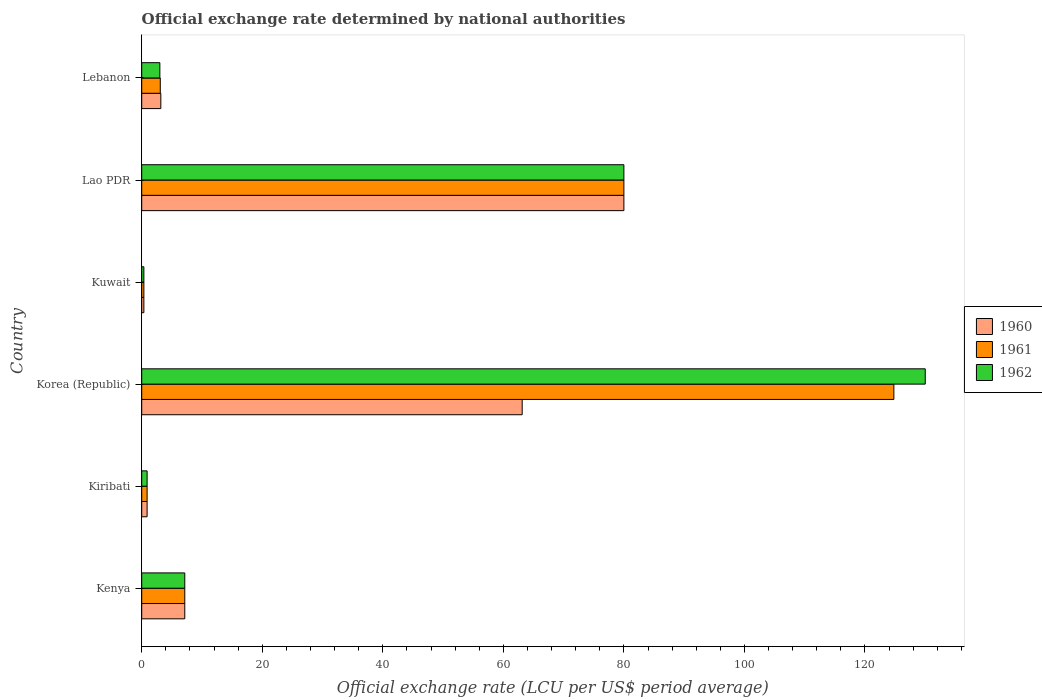How many different coloured bars are there?
Your response must be concise. 3. How many groups of bars are there?
Offer a very short reply. 6. Are the number of bars on each tick of the Y-axis equal?
Your answer should be compact. Yes. What is the label of the 6th group of bars from the top?
Offer a very short reply. Kenya. What is the official exchange rate in 1961 in Korea (Republic)?
Offer a terse response. 124.79. Across all countries, what is the maximum official exchange rate in 1962?
Your answer should be compact. 130. Across all countries, what is the minimum official exchange rate in 1962?
Give a very brief answer. 0.36. In which country was the official exchange rate in 1962 minimum?
Provide a succinct answer. Kuwait. What is the total official exchange rate in 1962 in the graph?
Make the answer very short. 221.4. What is the difference between the official exchange rate in 1960 in Kenya and that in Korea (Republic)?
Provide a succinct answer. -55.98. What is the difference between the official exchange rate in 1961 in Kiribati and the official exchange rate in 1960 in Kenya?
Give a very brief answer. -6.25. What is the average official exchange rate in 1962 per country?
Your response must be concise. 36.9. In how many countries, is the official exchange rate in 1961 greater than 128 LCU?
Provide a succinct answer. 0. What is the ratio of the official exchange rate in 1962 in Kiribati to that in Kuwait?
Your answer should be very brief. 2.5. Is the official exchange rate in 1961 in Kuwait less than that in Lao PDR?
Your response must be concise. Yes. Is the difference between the official exchange rate in 1960 in Kenya and Lebanon greater than the difference between the official exchange rate in 1961 in Kenya and Lebanon?
Offer a very short reply. No. What is the difference between the highest and the second highest official exchange rate in 1961?
Ensure brevity in your answer.  44.79. What is the difference between the highest and the lowest official exchange rate in 1960?
Offer a terse response. 79.64. In how many countries, is the official exchange rate in 1961 greater than the average official exchange rate in 1961 taken over all countries?
Offer a terse response. 2. Is the sum of the official exchange rate in 1960 in Korea (Republic) and Lao PDR greater than the maximum official exchange rate in 1961 across all countries?
Offer a very short reply. Yes. What does the 1st bar from the top in Lao PDR represents?
Ensure brevity in your answer.  1962. What does the 3rd bar from the bottom in Kuwait represents?
Your response must be concise. 1962. Is it the case that in every country, the sum of the official exchange rate in 1962 and official exchange rate in 1960 is greater than the official exchange rate in 1961?
Offer a terse response. Yes. How are the legend labels stacked?
Give a very brief answer. Vertical. What is the title of the graph?
Keep it short and to the point. Official exchange rate determined by national authorities. What is the label or title of the X-axis?
Provide a short and direct response. Official exchange rate (LCU per US$ period average). What is the Official exchange rate (LCU per US$ period average) in 1960 in Kenya?
Keep it short and to the point. 7.14. What is the Official exchange rate (LCU per US$ period average) of 1961 in Kenya?
Provide a succinct answer. 7.14. What is the Official exchange rate (LCU per US$ period average) in 1962 in Kenya?
Keep it short and to the point. 7.14. What is the Official exchange rate (LCU per US$ period average) in 1960 in Kiribati?
Your answer should be compact. 0.89. What is the Official exchange rate (LCU per US$ period average) of 1961 in Kiribati?
Offer a terse response. 0.89. What is the Official exchange rate (LCU per US$ period average) in 1962 in Kiribati?
Offer a terse response. 0.89. What is the Official exchange rate (LCU per US$ period average) of 1960 in Korea (Republic)?
Make the answer very short. 63.12. What is the Official exchange rate (LCU per US$ period average) in 1961 in Korea (Republic)?
Make the answer very short. 124.79. What is the Official exchange rate (LCU per US$ period average) in 1962 in Korea (Republic)?
Provide a succinct answer. 130. What is the Official exchange rate (LCU per US$ period average) of 1960 in Kuwait?
Provide a succinct answer. 0.36. What is the Official exchange rate (LCU per US$ period average) of 1961 in Kuwait?
Keep it short and to the point. 0.36. What is the Official exchange rate (LCU per US$ period average) of 1962 in Kuwait?
Your answer should be very brief. 0.36. What is the Official exchange rate (LCU per US$ period average) of 1960 in Lao PDR?
Provide a short and direct response. 80. What is the Official exchange rate (LCU per US$ period average) in 1961 in Lao PDR?
Provide a short and direct response. 80. What is the Official exchange rate (LCU per US$ period average) of 1962 in Lao PDR?
Offer a very short reply. 80. What is the Official exchange rate (LCU per US$ period average) in 1960 in Lebanon?
Provide a short and direct response. 3.17. What is the Official exchange rate (LCU per US$ period average) in 1961 in Lebanon?
Make the answer very short. 3.08. What is the Official exchange rate (LCU per US$ period average) of 1962 in Lebanon?
Offer a terse response. 3.01. Across all countries, what is the maximum Official exchange rate (LCU per US$ period average) in 1960?
Offer a terse response. 80. Across all countries, what is the maximum Official exchange rate (LCU per US$ period average) of 1961?
Give a very brief answer. 124.79. Across all countries, what is the maximum Official exchange rate (LCU per US$ period average) of 1962?
Provide a short and direct response. 130. Across all countries, what is the minimum Official exchange rate (LCU per US$ period average) in 1960?
Your answer should be compact. 0.36. Across all countries, what is the minimum Official exchange rate (LCU per US$ period average) of 1961?
Give a very brief answer. 0.36. Across all countries, what is the minimum Official exchange rate (LCU per US$ period average) of 1962?
Ensure brevity in your answer.  0.36. What is the total Official exchange rate (LCU per US$ period average) in 1960 in the graph?
Your response must be concise. 154.69. What is the total Official exchange rate (LCU per US$ period average) in 1961 in the graph?
Offer a terse response. 216.26. What is the total Official exchange rate (LCU per US$ period average) of 1962 in the graph?
Your response must be concise. 221.4. What is the difference between the Official exchange rate (LCU per US$ period average) of 1960 in Kenya and that in Kiribati?
Provide a short and direct response. 6.25. What is the difference between the Official exchange rate (LCU per US$ period average) of 1961 in Kenya and that in Kiribati?
Your answer should be compact. 6.25. What is the difference between the Official exchange rate (LCU per US$ period average) in 1962 in Kenya and that in Kiribati?
Offer a very short reply. 6.25. What is the difference between the Official exchange rate (LCU per US$ period average) in 1960 in Kenya and that in Korea (Republic)?
Your answer should be compact. -55.98. What is the difference between the Official exchange rate (LCU per US$ period average) in 1961 in Kenya and that in Korea (Republic)?
Ensure brevity in your answer.  -117.65. What is the difference between the Official exchange rate (LCU per US$ period average) in 1962 in Kenya and that in Korea (Republic)?
Give a very brief answer. -122.86. What is the difference between the Official exchange rate (LCU per US$ period average) of 1960 in Kenya and that in Kuwait?
Provide a short and direct response. 6.79. What is the difference between the Official exchange rate (LCU per US$ period average) in 1961 in Kenya and that in Kuwait?
Your answer should be very brief. 6.79. What is the difference between the Official exchange rate (LCU per US$ period average) in 1962 in Kenya and that in Kuwait?
Offer a very short reply. 6.79. What is the difference between the Official exchange rate (LCU per US$ period average) in 1960 in Kenya and that in Lao PDR?
Your answer should be very brief. -72.86. What is the difference between the Official exchange rate (LCU per US$ period average) in 1961 in Kenya and that in Lao PDR?
Your response must be concise. -72.86. What is the difference between the Official exchange rate (LCU per US$ period average) in 1962 in Kenya and that in Lao PDR?
Your answer should be compact. -72.86. What is the difference between the Official exchange rate (LCU per US$ period average) in 1960 in Kenya and that in Lebanon?
Your response must be concise. 3.97. What is the difference between the Official exchange rate (LCU per US$ period average) in 1961 in Kenya and that in Lebanon?
Your answer should be very brief. 4.06. What is the difference between the Official exchange rate (LCU per US$ period average) in 1962 in Kenya and that in Lebanon?
Provide a succinct answer. 4.13. What is the difference between the Official exchange rate (LCU per US$ period average) of 1960 in Kiribati and that in Korea (Republic)?
Your answer should be very brief. -62.23. What is the difference between the Official exchange rate (LCU per US$ period average) in 1961 in Kiribati and that in Korea (Republic)?
Your answer should be very brief. -123.9. What is the difference between the Official exchange rate (LCU per US$ period average) of 1962 in Kiribati and that in Korea (Republic)?
Offer a very short reply. -129.11. What is the difference between the Official exchange rate (LCU per US$ period average) in 1960 in Kiribati and that in Kuwait?
Provide a short and direct response. 0.54. What is the difference between the Official exchange rate (LCU per US$ period average) of 1961 in Kiribati and that in Kuwait?
Give a very brief answer. 0.54. What is the difference between the Official exchange rate (LCU per US$ period average) of 1962 in Kiribati and that in Kuwait?
Give a very brief answer. 0.54. What is the difference between the Official exchange rate (LCU per US$ period average) in 1960 in Kiribati and that in Lao PDR?
Provide a short and direct response. -79.11. What is the difference between the Official exchange rate (LCU per US$ period average) in 1961 in Kiribati and that in Lao PDR?
Your answer should be very brief. -79.11. What is the difference between the Official exchange rate (LCU per US$ period average) in 1962 in Kiribati and that in Lao PDR?
Provide a succinct answer. -79.11. What is the difference between the Official exchange rate (LCU per US$ period average) of 1960 in Kiribati and that in Lebanon?
Make the answer very short. -2.28. What is the difference between the Official exchange rate (LCU per US$ period average) in 1961 in Kiribati and that in Lebanon?
Make the answer very short. -2.19. What is the difference between the Official exchange rate (LCU per US$ period average) in 1962 in Kiribati and that in Lebanon?
Your answer should be compact. -2.12. What is the difference between the Official exchange rate (LCU per US$ period average) in 1960 in Korea (Republic) and that in Kuwait?
Make the answer very short. 62.77. What is the difference between the Official exchange rate (LCU per US$ period average) of 1961 in Korea (Republic) and that in Kuwait?
Keep it short and to the point. 124.43. What is the difference between the Official exchange rate (LCU per US$ period average) of 1962 in Korea (Republic) and that in Kuwait?
Make the answer very short. 129.64. What is the difference between the Official exchange rate (LCU per US$ period average) in 1960 in Korea (Republic) and that in Lao PDR?
Ensure brevity in your answer.  -16.88. What is the difference between the Official exchange rate (LCU per US$ period average) in 1961 in Korea (Republic) and that in Lao PDR?
Ensure brevity in your answer.  44.79. What is the difference between the Official exchange rate (LCU per US$ period average) in 1962 in Korea (Republic) and that in Lao PDR?
Make the answer very short. 50. What is the difference between the Official exchange rate (LCU per US$ period average) of 1960 in Korea (Republic) and that in Lebanon?
Offer a very short reply. 59.96. What is the difference between the Official exchange rate (LCU per US$ period average) in 1961 in Korea (Republic) and that in Lebanon?
Make the answer very short. 121.71. What is the difference between the Official exchange rate (LCU per US$ period average) of 1962 in Korea (Republic) and that in Lebanon?
Give a very brief answer. 126.99. What is the difference between the Official exchange rate (LCU per US$ period average) of 1960 in Kuwait and that in Lao PDR?
Offer a terse response. -79.64. What is the difference between the Official exchange rate (LCU per US$ period average) of 1961 in Kuwait and that in Lao PDR?
Offer a very short reply. -79.64. What is the difference between the Official exchange rate (LCU per US$ period average) in 1962 in Kuwait and that in Lao PDR?
Your answer should be compact. -79.64. What is the difference between the Official exchange rate (LCU per US$ period average) of 1960 in Kuwait and that in Lebanon?
Keep it short and to the point. -2.81. What is the difference between the Official exchange rate (LCU per US$ period average) in 1961 in Kuwait and that in Lebanon?
Offer a terse response. -2.72. What is the difference between the Official exchange rate (LCU per US$ period average) in 1962 in Kuwait and that in Lebanon?
Give a very brief answer. -2.65. What is the difference between the Official exchange rate (LCU per US$ period average) in 1960 in Lao PDR and that in Lebanon?
Offer a terse response. 76.83. What is the difference between the Official exchange rate (LCU per US$ period average) of 1961 in Lao PDR and that in Lebanon?
Your answer should be compact. 76.92. What is the difference between the Official exchange rate (LCU per US$ period average) of 1962 in Lao PDR and that in Lebanon?
Keep it short and to the point. 76.99. What is the difference between the Official exchange rate (LCU per US$ period average) of 1960 in Kenya and the Official exchange rate (LCU per US$ period average) of 1961 in Kiribati?
Give a very brief answer. 6.25. What is the difference between the Official exchange rate (LCU per US$ period average) of 1960 in Kenya and the Official exchange rate (LCU per US$ period average) of 1962 in Kiribati?
Provide a short and direct response. 6.25. What is the difference between the Official exchange rate (LCU per US$ period average) of 1961 in Kenya and the Official exchange rate (LCU per US$ period average) of 1962 in Kiribati?
Your answer should be very brief. 6.25. What is the difference between the Official exchange rate (LCU per US$ period average) of 1960 in Kenya and the Official exchange rate (LCU per US$ period average) of 1961 in Korea (Republic)?
Keep it short and to the point. -117.65. What is the difference between the Official exchange rate (LCU per US$ period average) of 1960 in Kenya and the Official exchange rate (LCU per US$ period average) of 1962 in Korea (Republic)?
Provide a short and direct response. -122.86. What is the difference between the Official exchange rate (LCU per US$ period average) in 1961 in Kenya and the Official exchange rate (LCU per US$ period average) in 1962 in Korea (Republic)?
Make the answer very short. -122.86. What is the difference between the Official exchange rate (LCU per US$ period average) of 1960 in Kenya and the Official exchange rate (LCU per US$ period average) of 1961 in Kuwait?
Your answer should be very brief. 6.79. What is the difference between the Official exchange rate (LCU per US$ period average) in 1960 in Kenya and the Official exchange rate (LCU per US$ period average) in 1962 in Kuwait?
Give a very brief answer. 6.79. What is the difference between the Official exchange rate (LCU per US$ period average) in 1961 in Kenya and the Official exchange rate (LCU per US$ period average) in 1962 in Kuwait?
Your answer should be compact. 6.79. What is the difference between the Official exchange rate (LCU per US$ period average) in 1960 in Kenya and the Official exchange rate (LCU per US$ period average) in 1961 in Lao PDR?
Give a very brief answer. -72.86. What is the difference between the Official exchange rate (LCU per US$ period average) in 1960 in Kenya and the Official exchange rate (LCU per US$ period average) in 1962 in Lao PDR?
Offer a terse response. -72.86. What is the difference between the Official exchange rate (LCU per US$ period average) of 1961 in Kenya and the Official exchange rate (LCU per US$ period average) of 1962 in Lao PDR?
Offer a very short reply. -72.86. What is the difference between the Official exchange rate (LCU per US$ period average) of 1960 in Kenya and the Official exchange rate (LCU per US$ period average) of 1961 in Lebanon?
Provide a short and direct response. 4.06. What is the difference between the Official exchange rate (LCU per US$ period average) in 1960 in Kenya and the Official exchange rate (LCU per US$ period average) in 1962 in Lebanon?
Your answer should be very brief. 4.13. What is the difference between the Official exchange rate (LCU per US$ period average) of 1961 in Kenya and the Official exchange rate (LCU per US$ period average) of 1962 in Lebanon?
Provide a short and direct response. 4.13. What is the difference between the Official exchange rate (LCU per US$ period average) in 1960 in Kiribati and the Official exchange rate (LCU per US$ period average) in 1961 in Korea (Republic)?
Keep it short and to the point. -123.9. What is the difference between the Official exchange rate (LCU per US$ period average) of 1960 in Kiribati and the Official exchange rate (LCU per US$ period average) of 1962 in Korea (Republic)?
Offer a terse response. -129.11. What is the difference between the Official exchange rate (LCU per US$ period average) of 1961 in Kiribati and the Official exchange rate (LCU per US$ period average) of 1962 in Korea (Republic)?
Your answer should be compact. -129.11. What is the difference between the Official exchange rate (LCU per US$ period average) in 1960 in Kiribati and the Official exchange rate (LCU per US$ period average) in 1961 in Kuwait?
Provide a short and direct response. 0.54. What is the difference between the Official exchange rate (LCU per US$ period average) in 1960 in Kiribati and the Official exchange rate (LCU per US$ period average) in 1962 in Kuwait?
Provide a short and direct response. 0.54. What is the difference between the Official exchange rate (LCU per US$ period average) of 1961 in Kiribati and the Official exchange rate (LCU per US$ period average) of 1962 in Kuwait?
Keep it short and to the point. 0.54. What is the difference between the Official exchange rate (LCU per US$ period average) of 1960 in Kiribati and the Official exchange rate (LCU per US$ period average) of 1961 in Lao PDR?
Make the answer very short. -79.11. What is the difference between the Official exchange rate (LCU per US$ period average) in 1960 in Kiribati and the Official exchange rate (LCU per US$ period average) in 1962 in Lao PDR?
Ensure brevity in your answer.  -79.11. What is the difference between the Official exchange rate (LCU per US$ period average) of 1961 in Kiribati and the Official exchange rate (LCU per US$ period average) of 1962 in Lao PDR?
Offer a very short reply. -79.11. What is the difference between the Official exchange rate (LCU per US$ period average) in 1960 in Kiribati and the Official exchange rate (LCU per US$ period average) in 1961 in Lebanon?
Offer a very short reply. -2.19. What is the difference between the Official exchange rate (LCU per US$ period average) in 1960 in Kiribati and the Official exchange rate (LCU per US$ period average) in 1962 in Lebanon?
Offer a very short reply. -2.12. What is the difference between the Official exchange rate (LCU per US$ period average) of 1961 in Kiribati and the Official exchange rate (LCU per US$ period average) of 1962 in Lebanon?
Make the answer very short. -2.12. What is the difference between the Official exchange rate (LCU per US$ period average) of 1960 in Korea (Republic) and the Official exchange rate (LCU per US$ period average) of 1961 in Kuwait?
Offer a terse response. 62.77. What is the difference between the Official exchange rate (LCU per US$ period average) of 1960 in Korea (Republic) and the Official exchange rate (LCU per US$ period average) of 1962 in Kuwait?
Your answer should be very brief. 62.77. What is the difference between the Official exchange rate (LCU per US$ period average) in 1961 in Korea (Republic) and the Official exchange rate (LCU per US$ period average) in 1962 in Kuwait?
Your answer should be compact. 124.43. What is the difference between the Official exchange rate (LCU per US$ period average) of 1960 in Korea (Republic) and the Official exchange rate (LCU per US$ period average) of 1961 in Lao PDR?
Keep it short and to the point. -16.88. What is the difference between the Official exchange rate (LCU per US$ period average) in 1960 in Korea (Republic) and the Official exchange rate (LCU per US$ period average) in 1962 in Lao PDR?
Offer a terse response. -16.88. What is the difference between the Official exchange rate (LCU per US$ period average) in 1961 in Korea (Republic) and the Official exchange rate (LCU per US$ period average) in 1962 in Lao PDR?
Provide a short and direct response. 44.79. What is the difference between the Official exchange rate (LCU per US$ period average) of 1960 in Korea (Republic) and the Official exchange rate (LCU per US$ period average) of 1961 in Lebanon?
Provide a short and direct response. 60.05. What is the difference between the Official exchange rate (LCU per US$ period average) of 1960 in Korea (Republic) and the Official exchange rate (LCU per US$ period average) of 1962 in Lebanon?
Ensure brevity in your answer.  60.12. What is the difference between the Official exchange rate (LCU per US$ period average) of 1961 in Korea (Republic) and the Official exchange rate (LCU per US$ period average) of 1962 in Lebanon?
Give a very brief answer. 121.78. What is the difference between the Official exchange rate (LCU per US$ period average) of 1960 in Kuwait and the Official exchange rate (LCU per US$ period average) of 1961 in Lao PDR?
Offer a terse response. -79.64. What is the difference between the Official exchange rate (LCU per US$ period average) in 1960 in Kuwait and the Official exchange rate (LCU per US$ period average) in 1962 in Lao PDR?
Your response must be concise. -79.64. What is the difference between the Official exchange rate (LCU per US$ period average) of 1961 in Kuwait and the Official exchange rate (LCU per US$ period average) of 1962 in Lao PDR?
Ensure brevity in your answer.  -79.64. What is the difference between the Official exchange rate (LCU per US$ period average) of 1960 in Kuwait and the Official exchange rate (LCU per US$ period average) of 1961 in Lebanon?
Provide a short and direct response. -2.72. What is the difference between the Official exchange rate (LCU per US$ period average) in 1960 in Kuwait and the Official exchange rate (LCU per US$ period average) in 1962 in Lebanon?
Provide a succinct answer. -2.65. What is the difference between the Official exchange rate (LCU per US$ period average) of 1961 in Kuwait and the Official exchange rate (LCU per US$ period average) of 1962 in Lebanon?
Provide a short and direct response. -2.65. What is the difference between the Official exchange rate (LCU per US$ period average) in 1960 in Lao PDR and the Official exchange rate (LCU per US$ period average) in 1961 in Lebanon?
Provide a succinct answer. 76.92. What is the difference between the Official exchange rate (LCU per US$ period average) of 1960 in Lao PDR and the Official exchange rate (LCU per US$ period average) of 1962 in Lebanon?
Ensure brevity in your answer.  76.99. What is the difference between the Official exchange rate (LCU per US$ period average) of 1961 in Lao PDR and the Official exchange rate (LCU per US$ period average) of 1962 in Lebanon?
Your response must be concise. 76.99. What is the average Official exchange rate (LCU per US$ period average) of 1960 per country?
Keep it short and to the point. 25.78. What is the average Official exchange rate (LCU per US$ period average) in 1961 per country?
Provide a short and direct response. 36.04. What is the average Official exchange rate (LCU per US$ period average) in 1962 per country?
Offer a terse response. 36.9. What is the difference between the Official exchange rate (LCU per US$ period average) in 1960 and Official exchange rate (LCU per US$ period average) in 1961 in Kenya?
Make the answer very short. 0. What is the difference between the Official exchange rate (LCU per US$ period average) in 1960 and Official exchange rate (LCU per US$ period average) in 1962 in Kenya?
Your answer should be compact. 0. What is the difference between the Official exchange rate (LCU per US$ period average) of 1960 and Official exchange rate (LCU per US$ period average) of 1961 in Kiribati?
Provide a short and direct response. 0. What is the difference between the Official exchange rate (LCU per US$ period average) in 1961 and Official exchange rate (LCU per US$ period average) in 1962 in Kiribati?
Offer a terse response. 0. What is the difference between the Official exchange rate (LCU per US$ period average) in 1960 and Official exchange rate (LCU per US$ period average) in 1961 in Korea (Republic)?
Offer a very short reply. -61.67. What is the difference between the Official exchange rate (LCU per US$ period average) of 1960 and Official exchange rate (LCU per US$ period average) of 1962 in Korea (Republic)?
Your response must be concise. -66.88. What is the difference between the Official exchange rate (LCU per US$ period average) in 1961 and Official exchange rate (LCU per US$ period average) in 1962 in Korea (Republic)?
Offer a terse response. -5.21. What is the difference between the Official exchange rate (LCU per US$ period average) of 1960 and Official exchange rate (LCU per US$ period average) of 1961 in Kuwait?
Give a very brief answer. 0. What is the difference between the Official exchange rate (LCU per US$ period average) in 1961 and Official exchange rate (LCU per US$ period average) in 1962 in Lao PDR?
Give a very brief answer. 0. What is the difference between the Official exchange rate (LCU per US$ period average) of 1960 and Official exchange rate (LCU per US$ period average) of 1961 in Lebanon?
Make the answer very short. 0.09. What is the difference between the Official exchange rate (LCU per US$ period average) of 1960 and Official exchange rate (LCU per US$ period average) of 1962 in Lebanon?
Your response must be concise. 0.16. What is the difference between the Official exchange rate (LCU per US$ period average) of 1961 and Official exchange rate (LCU per US$ period average) of 1962 in Lebanon?
Your response must be concise. 0.07. What is the ratio of the Official exchange rate (LCU per US$ period average) of 1961 in Kenya to that in Kiribati?
Provide a succinct answer. 8. What is the ratio of the Official exchange rate (LCU per US$ period average) of 1962 in Kenya to that in Kiribati?
Provide a short and direct response. 8. What is the ratio of the Official exchange rate (LCU per US$ period average) of 1960 in Kenya to that in Korea (Republic)?
Provide a succinct answer. 0.11. What is the ratio of the Official exchange rate (LCU per US$ period average) in 1961 in Kenya to that in Korea (Republic)?
Provide a short and direct response. 0.06. What is the ratio of the Official exchange rate (LCU per US$ period average) in 1962 in Kenya to that in Korea (Republic)?
Provide a short and direct response. 0.05. What is the ratio of the Official exchange rate (LCU per US$ period average) of 1960 in Kenya to that in Kuwait?
Give a very brief answer. 20. What is the ratio of the Official exchange rate (LCU per US$ period average) of 1961 in Kenya to that in Kuwait?
Ensure brevity in your answer.  20. What is the ratio of the Official exchange rate (LCU per US$ period average) of 1960 in Kenya to that in Lao PDR?
Give a very brief answer. 0.09. What is the ratio of the Official exchange rate (LCU per US$ period average) in 1961 in Kenya to that in Lao PDR?
Keep it short and to the point. 0.09. What is the ratio of the Official exchange rate (LCU per US$ period average) of 1962 in Kenya to that in Lao PDR?
Make the answer very short. 0.09. What is the ratio of the Official exchange rate (LCU per US$ period average) in 1960 in Kenya to that in Lebanon?
Your answer should be compact. 2.25. What is the ratio of the Official exchange rate (LCU per US$ period average) in 1961 in Kenya to that in Lebanon?
Give a very brief answer. 2.32. What is the ratio of the Official exchange rate (LCU per US$ period average) in 1962 in Kenya to that in Lebanon?
Your answer should be very brief. 2.37. What is the ratio of the Official exchange rate (LCU per US$ period average) of 1960 in Kiribati to that in Korea (Republic)?
Offer a very short reply. 0.01. What is the ratio of the Official exchange rate (LCU per US$ period average) of 1961 in Kiribati to that in Korea (Republic)?
Your answer should be very brief. 0.01. What is the ratio of the Official exchange rate (LCU per US$ period average) in 1962 in Kiribati to that in Korea (Republic)?
Your response must be concise. 0.01. What is the ratio of the Official exchange rate (LCU per US$ period average) in 1960 in Kiribati to that in Lao PDR?
Your answer should be very brief. 0.01. What is the ratio of the Official exchange rate (LCU per US$ period average) in 1961 in Kiribati to that in Lao PDR?
Keep it short and to the point. 0.01. What is the ratio of the Official exchange rate (LCU per US$ period average) of 1962 in Kiribati to that in Lao PDR?
Offer a terse response. 0.01. What is the ratio of the Official exchange rate (LCU per US$ period average) in 1960 in Kiribati to that in Lebanon?
Your response must be concise. 0.28. What is the ratio of the Official exchange rate (LCU per US$ period average) of 1961 in Kiribati to that in Lebanon?
Make the answer very short. 0.29. What is the ratio of the Official exchange rate (LCU per US$ period average) of 1962 in Kiribati to that in Lebanon?
Provide a short and direct response. 0.3. What is the ratio of the Official exchange rate (LCU per US$ period average) of 1960 in Korea (Republic) to that in Kuwait?
Keep it short and to the point. 176.75. What is the ratio of the Official exchange rate (LCU per US$ period average) in 1961 in Korea (Republic) to that in Kuwait?
Your response must be concise. 349.42. What is the ratio of the Official exchange rate (LCU per US$ period average) in 1962 in Korea (Republic) to that in Kuwait?
Give a very brief answer. 364. What is the ratio of the Official exchange rate (LCU per US$ period average) in 1960 in Korea (Republic) to that in Lao PDR?
Offer a terse response. 0.79. What is the ratio of the Official exchange rate (LCU per US$ period average) in 1961 in Korea (Republic) to that in Lao PDR?
Provide a succinct answer. 1.56. What is the ratio of the Official exchange rate (LCU per US$ period average) in 1962 in Korea (Republic) to that in Lao PDR?
Provide a short and direct response. 1.62. What is the ratio of the Official exchange rate (LCU per US$ period average) of 1960 in Korea (Republic) to that in Lebanon?
Give a very brief answer. 19.92. What is the ratio of the Official exchange rate (LCU per US$ period average) in 1961 in Korea (Republic) to that in Lebanon?
Provide a short and direct response. 40.53. What is the ratio of the Official exchange rate (LCU per US$ period average) of 1962 in Korea (Republic) to that in Lebanon?
Your response must be concise. 43.2. What is the ratio of the Official exchange rate (LCU per US$ period average) of 1960 in Kuwait to that in Lao PDR?
Your answer should be very brief. 0. What is the ratio of the Official exchange rate (LCU per US$ period average) of 1961 in Kuwait to that in Lao PDR?
Your answer should be compact. 0. What is the ratio of the Official exchange rate (LCU per US$ period average) in 1962 in Kuwait to that in Lao PDR?
Offer a very short reply. 0. What is the ratio of the Official exchange rate (LCU per US$ period average) of 1960 in Kuwait to that in Lebanon?
Your answer should be compact. 0.11. What is the ratio of the Official exchange rate (LCU per US$ period average) in 1961 in Kuwait to that in Lebanon?
Offer a very short reply. 0.12. What is the ratio of the Official exchange rate (LCU per US$ period average) of 1962 in Kuwait to that in Lebanon?
Your answer should be very brief. 0.12. What is the ratio of the Official exchange rate (LCU per US$ period average) of 1960 in Lao PDR to that in Lebanon?
Keep it short and to the point. 25.24. What is the ratio of the Official exchange rate (LCU per US$ period average) in 1961 in Lao PDR to that in Lebanon?
Your response must be concise. 25.99. What is the ratio of the Official exchange rate (LCU per US$ period average) of 1962 in Lao PDR to that in Lebanon?
Offer a terse response. 26.59. What is the difference between the highest and the second highest Official exchange rate (LCU per US$ period average) in 1960?
Your answer should be compact. 16.88. What is the difference between the highest and the second highest Official exchange rate (LCU per US$ period average) in 1961?
Offer a very short reply. 44.79. What is the difference between the highest and the second highest Official exchange rate (LCU per US$ period average) of 1962?
Provide a short and direct response. 50. What is the difference between the highest and the lowest Official exchange rate (LCU per US$ period average) of 1960?
Offer a terse response. 79.64. What is the difference between the highest and the lowest Official exchange rate (LCU per US$ period average) in 1961?
Offer a very short reply. 124.43. What is the difference between the highest and the lowest Official exchange rate (LCU per US$ period average) in 1962?
Offer a terse response. 129.64. 